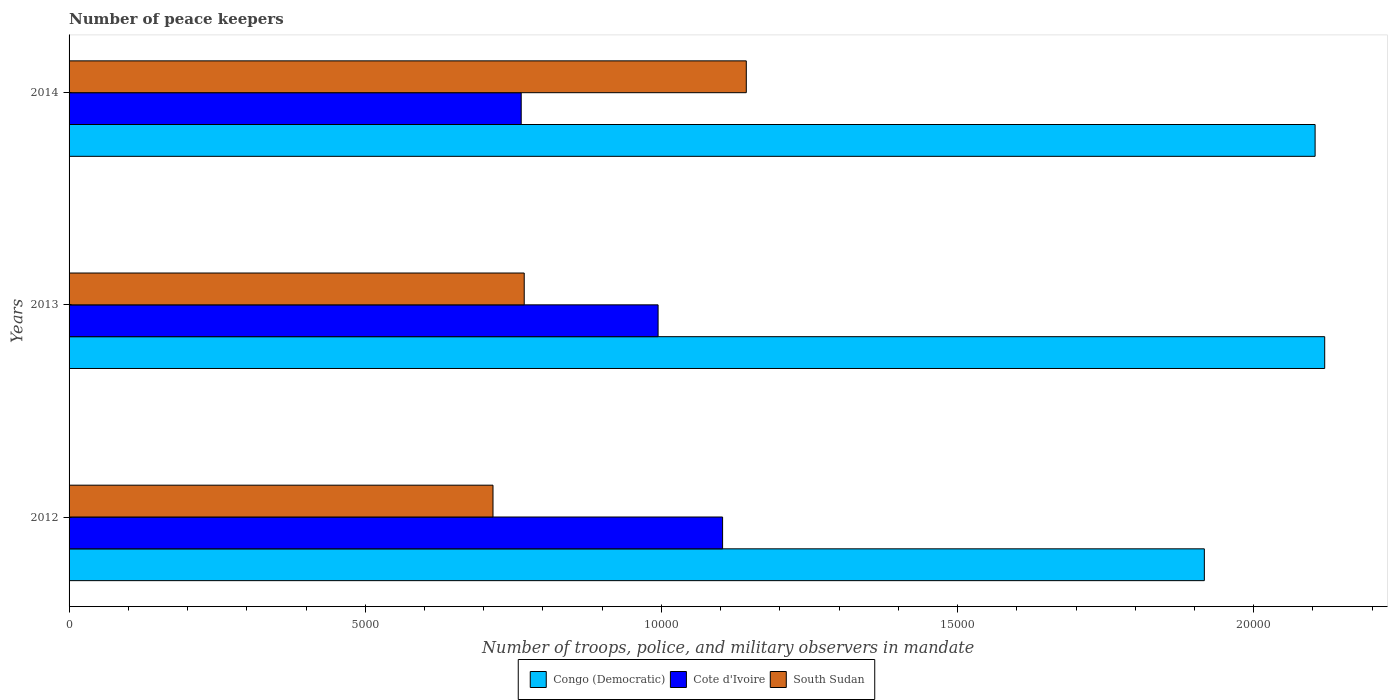How many bars are there on the 1st tick from the bottom?
Make the answer very short. 3. In how many cases, is the number of bars for a given year not equal to the number of legend labels?
Ensure brevity in your answer.  0. What is the number of peace keepers in in South Sudan in 2014?
Provide a succinct answer. 1.14e+04. Across all years, what is the maximum number of peace keepers in in Congo (Democratic)?
Provide a short and direct response. 2.12e+04. Across all years, what is the minimum number of peace keepers in in South Sudan?
Make the answer very short. 7157. What is the total number of peace keepers in in Cote d'Ivoire in the graph?
Your answer should be very brief. 2.86e+04. What is the difference between the number of peace keepers in in South Sudan in 2012 and that in 2013?
Your answer should be very brief. -527. What is the difference between the number of peace keepers in in Cote d'Ivoire in 2014 and the number of peace keepers in in South Sudan in 2013?
Offer a terse response. -51. What is the average number of peace keepers in in Congo (Democratic) per year?
Keep it short and to the point. 2.05e+04. In the year 2013, what is the difference between the number of peace keepers in in Cote d'Ivoire and number of peace keepers in in South Sudan?
Ensure brevity in your answer.  2260. In how many years, is the number of peace keepers in in South Sudan greater than 12000 ?
Your answer should be very brief. 0. What is the ratio of the number of peace keepers in in Cote d'Ivoire in 2012 to that in 2014?
Your response must be concise. 1.45. Is the difference between the number of peace keepers in in Cote d'Ivoire in 2012 and 2013 greater than the difference between the number of peace keepers in in South Sudan in 2012 and 2013?
Provide a short and direct response. Yes. What is the difference between the highest and the second highest number of peace keepers in in Congo (Democratic)?
Your answer should be very brief. 162. What is the difference between the highest and the lowest number of peace keepers in in Cote d'Ivoire?
Offer a terse response. 3400. In how many years, is the number of peace keepers in in South Sudan greater than the average number of peace keepers in in South Sudan taken over all years?
Ensure brevity in your answer.  1. What does the 3rd bar from the top in 2013 represents?
Your response must be concise. Congo (Democratic). What does the 3rd bar from the bottom in 2013 represents?
Give a very brief answer. South Sudan. Is it the case that in every year, the sum of the number of peace keepers in in Cote d'Ivoire and number of peace keepers in in Congo (Democratic) is greater than the number of peace keepers in in South Sudan?
Ensure brevity in your answer.  Yes. What is the difference between two consecutive major ticks on the X-axis?
Your response must be concise. 5000. Does the graph contain grids?
Offer a terse response. No. How are the legend labels stacked?
Keep it short and to the point. Horizontal. What is the title of the graph?
Your answer should be compact. Number of peace keepers. What is the label or title of the X-axis?
Offer a terse response. Number of troops, police, and military observers in mandate. What is the label or title of the Y-axis?
Provide a succinct answer. Years. What is the Number of troops, police, and military observers in mandate in Congo (Democratic) in 2012?
Your answer should be very brief. 1.92e+04. What is the Number of troops, police, and military observers in mandate of Cote d'Ivoire in 2012?
Give a very brief answer. 1.10e+04. What is the Number of troops, police, and military observers in mandate of South Sudan in 2012?
Keep it short and to the point. 7157. What is the Number of troops, police, and military observers in mandate of Congo (Democratic) in 2013?
Your answer should be very brief. 2.12e+04. What is the Number of troops, police, and military observers in mandate in Cote d'Ivoire in 2013?
Your response must be concise. 9944. What is the Number of troops, police, and military observers in mandate in South Sudan in 2013?
Offer a very short reply. 7684. What is the Number of troops, police, and military observers in mandate in Congo (Democratic) in 2014?
Your answer should be very brief. 2.10e+04. What is the Number of troops, police, and military observers in mandate of Cote d'Ivoire in 2014?
Your answer should be compact. 7633. What is the Number of troops, police, and military observers in mandate of South Sudan in 2014?
Your answer should be compact. 1.14e+04. Across all years, what is the maximum Number of troops, police, and military observers in mandate of Congo (Democratic)?
Offer a terse response. 2.12e+04. Across all years, what is the maximum Number of troops, police, and military observers in mandate in Cote d'Ivoire?
Offer a very short reply. 1.10e+04. Across all years, what is the maximum Number of troops, police, and military observers in mandate of South Sudan?
Your answer should be very brief. 1.14e+04. Across all years, what is the minimum Number of troops, police, and military observers in mandate in Congo (Democratic)?
Make the answer very short. 1.92e+04. Across all years, what is the minimum Number of troops, police, and military observers in mandate of Cote d'Ivoire?
Provide a short and direct response. 7633. Across all years, what is the minimum Number of troops, police, and military observers in mandate of South Sudan?
Provide a short and direct response. 7157. What is the total Number of troops, police, and military observers in mandate in Congo (Democratic) in the graph?
Ensure brevity in your answer.  6.14e+04. What is the total Number of troops, police, and military observers in mandate of Cote d'Ivoire in the graph?
Ensure brevity in your answer.  2.86e+04. What is the total Number of troops, police, and military observers in mandate of South Sudan in the graph?
Make the answer very short. 2.63e+04. What is the difference between the Number of troops, police, and military observers in mandate in Congo (Democratic) in 2012 and that in 2013?
Keep it short and to the point. -2032. What is the difference between the Number of troops, police, and military observers in mandate in Cote d'Ivoire in 2012 and that in 2013?
Make the answer very short. 1089. What is the difference between the Number of troops, police, and military observers in mandate of South Sudan in 2012 and that in 2013?
Your answer should be compact. -527. What is the difference between the Number of troops, police, and military observers in mandate of Congo (Democratic) in 2012 and that in 2014?
Provide a succinct answer. -1870. What is the difference between the Number of troops, police, and military observers in mandate in Cote d'Ivoire in 2012 and that in 2014?
Your response must be concise. 3400. What is the difference between the Number of troops, police, and military observers in mandate in South Sudan in 2012 and that in 2014?
Your answer should be very brief. -4276. What is the difference between the Number of troops, police, and military observers in mandate of Congo (Democratic) in 2013 and that in 2014?
Offer a terse response. 162. What is the difference between the Number of troops, police, and military observers in mandate in Cote d'Ivoire in 2013 and that in 2014?
Give a very brief answer. 2311. What is the difference between the Number of troops, police, and military observers in mandate in South Sudan in 2013 and that in 2014?
Provide a short and direct response. -3749. What is the difference between the Number of troops, police, and military observers in mandate in Congo (Democratic) in 2012 and the Number of troops, police, and military observers in mandate in Cote d'Ivoire in 2013?
Your answer should be compact. 9222. What is the difference between the Number of troops, police, and military observers in mandate of Congo (Democratic) in 2012 and the Number of troops, police, and military observers in mandate of South Sudan in 2013?
Offer a terse response. 1.15e+04. What is the difference between the Number of troops, police, and military observers in mandate in Cote d'Ivoire in 2012 and the Number of troops, police, and military observers in mandate in South Sudan in 2013?
Ensure brevity in your answer.  3349. What is the difference between the Number of troops, police, and military observers in mandate in Congo (Democratic) in 2012 and the Number of troops, police, and military observers in mandate in Cote d'Ivoire in 2014?
Make the answer very short. 1.15e+04. What is the difference between the Number of troops, police, and military observers in mandate of Congo (Democratic) in 2012 and the Number of troops, police, and military observers in mandate of South Sudan in 2014?
Make the answer very short. 7733. What is the difference between the Number of troops, police, and military observers in mandate in Cote d'Ivoire in 2012 and the Number of troops, police, and military observers in mandate in South Sudan in 2014?
Your response must be concise. -400. What is the difference between the Number of troops, police, and military observers in mandate of Congo (Democratic) in 2013 and the Number of troops, police, and military observers in mandate of Cote d'Ivoire in 2014?
Ensure brevity in your answer.  1.36e+04. What is the difference between the Number of troops, police, and military observers in mandate in Congo (Democratic) in 2013 and the Number of troops, police, and military observers in mandate in South Sudan in 2014?
Give a very brief answer. 9765. What is the difference between the Number of troops, police, and military observers in mandate in Cote d'Ivoire in 2013 and the Number of troops, police, and military observers in mandate in South Sudan in 2014?
Your response must be concise. -1489. What is the average Number of troops, police, and military observers in mandate in Congo (Democratic) per year?
Offer a very short reply. 2.05e+04. What is the average Number of troops, police, and military observers in mandate of Cote d'Ivoire per year?
Provide a short and direct response. 9536.67. What is the average Number of troops, police, and military observers in mandate in South Sudan per year?
Your answer should be very brief. 8758. In the year 2012, what is the difference between the Number of troops, police, and military observers in mandate in Congo (Democratic) and Number of troops, police, and military observers in mandate in Cote d'Ivoire?
Ensure brevity in your answer.  8133. In the year 2012, what is the difference between the Number of troops, police, and military observers in mandate of Congo (Democratic) and Number of troops, police, and military observers in mandate of South Sudan?
Ensure brevity in your answer.  1.20e+04. In the year 2012, what is the difference between the Number of troops, police, and military observers in mandate in Cote d'Ivoire and Number of troops, police, and military observers in mandate in South Sudan?
Ensure brevity in your answer.  3876. In the year 2013, what is the difference between the Number of troops, police, and military observers in mandate in Congo (Democratic) and Number of troops, police, and military observers in mandate in Cote d'Ivoire?
Your response must be concise. 1.13e+04. In the year 2013, what is the difference between the Number of troops, police, and military observers in mandate of Congo (Democratic) and Number of troops, police, and military observers in mandate of South Sudan?
Make the answer very short. 1.35e+04. In the year 2013, what is the difference between the Number of troops, police, and military observers in mandate of Cote d'Ivoire and Number of troops, police, and military observers in mandate of South Sudan?
Provide a succinct answer. 2260. In the year 2014, what is the difference between the Number of troops, police, and military observers in mandate in Congo (Democratic) and Number of troops, police, and military observers in mandate in Cote d'Ivoire?
Ensure brevity in your answer.  1.34e+04. In the year 2014, what is the difference between the Number of troops, police, and military observers in mandate in Congo (Democratic) and Number of troops, police, and military observers in mandate in South Sudan?
Keep it short and to the point. 9603. In the year 2014, what is the difference between the Number of troops, police, and military observers in mandate of Cote d'Ivoire and Number of troops, police, and military observers in mandate of South Sudan?
Give a very brief answer. -3800. What is the ratio of the Number of troops, police, and military observers in mandate of Congo (Democratic) in 2012 to that in 2013?
Offer a terse response. 0.9. What is the ratio of the Number of troops, police, and military observers in mandate in Cote d'Ivoire in 2012 to that in 2013?
Ensure brevity in your answer.  1.11. What is the ratio of the Number of troops, police, and military observers in mandate in South Sudan in 2012 to that in 2013?
Keep it short and to the point. 0.93. What is the ratio of the Number of troops, police, and military observers in mandate of Congo (Democratic) in 2012 to that in 2014?
Offer a very short reply. 0.91. What is the ratio of the Number of troops, police, and military observers in mandate in Cote d'Ivoire in 2012 to that in 2014?
Your response must be concise. 1.45. What is the ratio of the Number of troops, police, and military observers in mandate in South Sudan in 2012 to that in 2014?
Give a very brief answer. 0.63. What is the ratio of the Number of troops, police, and military observers in mandate of Congo (Democratic) in 2013 to that in 2014?
Your answer should be compact. 1.01. What is the ratio of the Number of troops, police, and military observers in mandate of Cote d'Ivoire in 2013 to that in 2014?
Offer a terse response. 1.3. What is the ratio of the Number of troops, police, and military observers in mandate of South Sudan in 2013 to that in 2014?
Keep it short and to the point. 0.67. What is the difference between the highest and the second highest Number of troops, police, and military observers in mandate of Congo (Democratic)?
Give a very brief answer. 162. What is the difference between the highest and the second highest Number of troops, police, and military observers in mandate in Cote d'Ivoire?
Provide a succinct answer. 1089. What is the difference between the highest and the second highest Number of troops, police, and military observers in mandate of South Sudan?
Provide a succinct answer. 3749. What is the difference between the highest and the lowest Number of troops, police, and military observers in mandate of Congo (Democratic)?
Your answer should be compact. 2032. What is the difference between the highest and the lowest Number of troops, police, and military observers in mandate of Cote d'Ivoire?
Offer a terse response. 3400. What is the difference between the highest and the lowest Number of troops, police, and military observers in mandate of South Sudan?
Provide a succinct answer. 4276. 